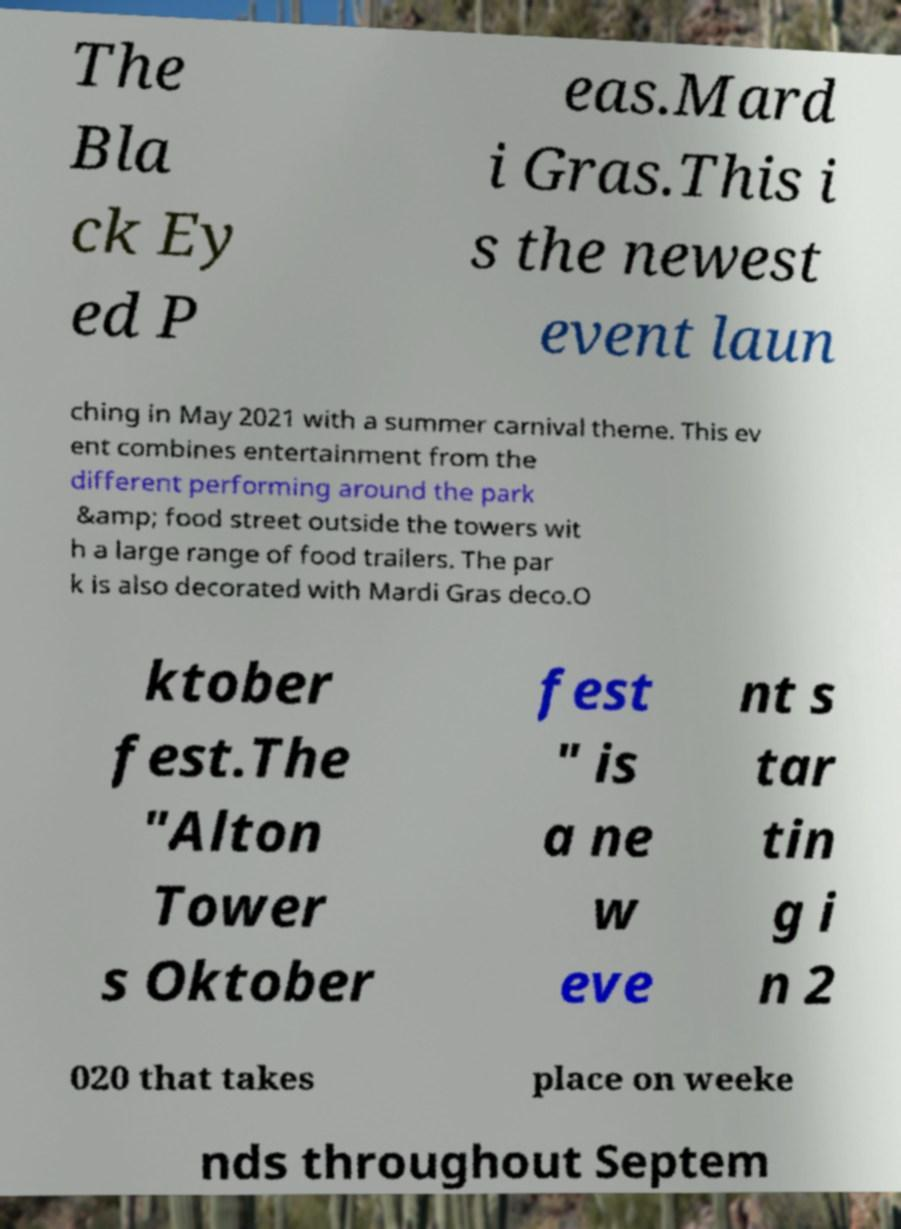Could you extract and type out the text from this image? The Bla ck Ey ed P eas.Mard i Gras.This i s the newest event laun ching in May 2021 with a summer carnival theme. This ev ent combines entertainment from the different performing around the park &amp; food street outside the towers wit h a large range of food trailers. The par k is also decorated with Mardi Gras deco.O ktober fest.The "Alton Tower s Oktober fest " is a ne w eve nt s tar tin g i n 2 020 that takes place on weeke nds throughout Septem 